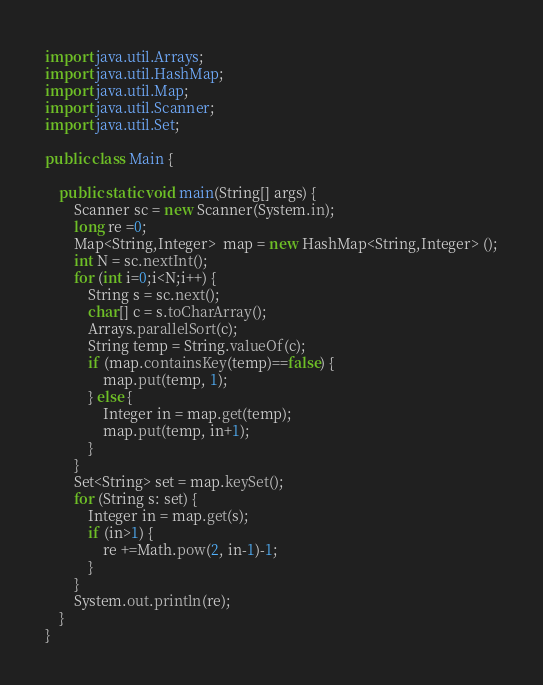Convert code to text. <code><loc_0><loc_0><loc_500><loc_500><_Java_>import java.util.Arrays;
import java.util.HashMap;
import java.util.Map;
import java.util.Scanner;
import java.util.Set;

public class Main {

	public static void main(String[] args) {
		Scanner sc = new Scanner(System.in);
		long re =0;
		Map<String,Integer>  map = new HashMap<String,Integer> ();
		int N = sc.nextInt();
		for (int i=0;i<N;i++) {
			String s = sc.next();
			char[] c = s.toCharArray();
			Arrays.parallelSort(c);
			String temp = String.valueOf(c);
			if (map.containsKey(temp)==false) {
				map.put(temp, 1);
			} else {
				Integer in = map.get(temp);
				map.put(temp, in+1);
			}
		}
		Set<String> set = map.keySet();
		for (String s: set) {
			Integer in = map.get(s);
			if (in>1) {
				re +=Math.pow(2, in-1)-1;
			}
		}
		System.out.println(re);
	}
}</code> 